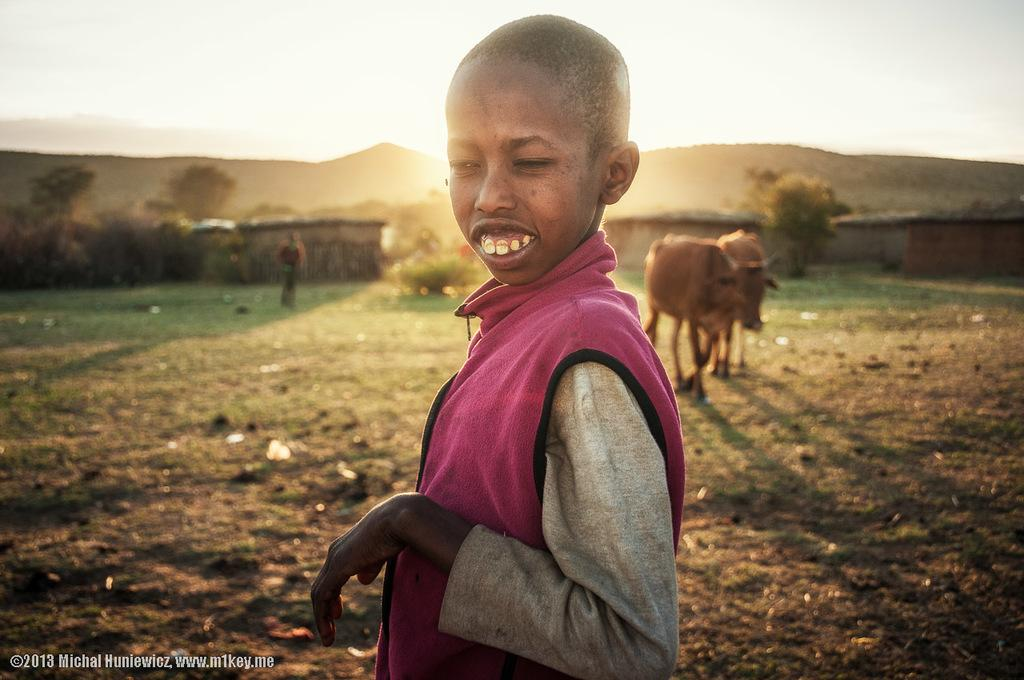What types of living beings are present in the image? There are people and animals in the image. What type of natural environment is depicted in the image? The image includes trees and plants, which are part of a natural environment. What can be seen in the background of the image? The sky is visible in the background of the image. Can you describe any additional features of the image? There is a watermark in the bottom left corner of the image. Who is the manager of the animals in the image? There is no indication in the image that there is a manager for the animals, as the image does not depict a specific context or situation involving animal management. 